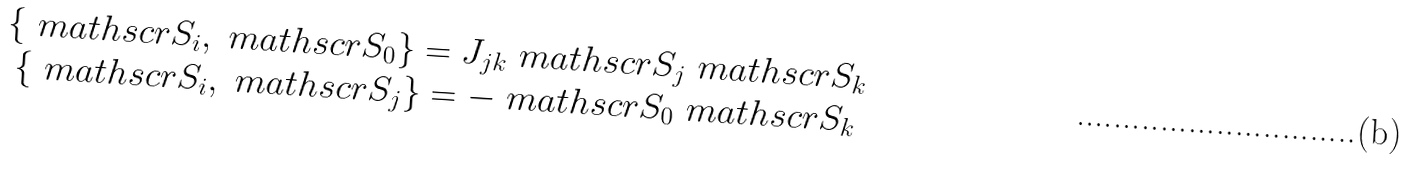<formula> <loc_0><loc_0><loc_500><loc_500>\begin{array} { c c } \{ \ m a t h s c r { S } _ { i } , \ m a t h s c r { S } _ { 0 } \} = J _ { j k } \ m a t h s c r { S } _ { j } \ m a t h s c r { S } _ { k } \\ \{ \ m a t h s c r { S } _ { i } , \ m a t h s c r { S } _ { j } \} = - \ m a t h s c r { S } _ { 0 } \ m a t h s c r { S } _ { k } \end{array}</formula> 